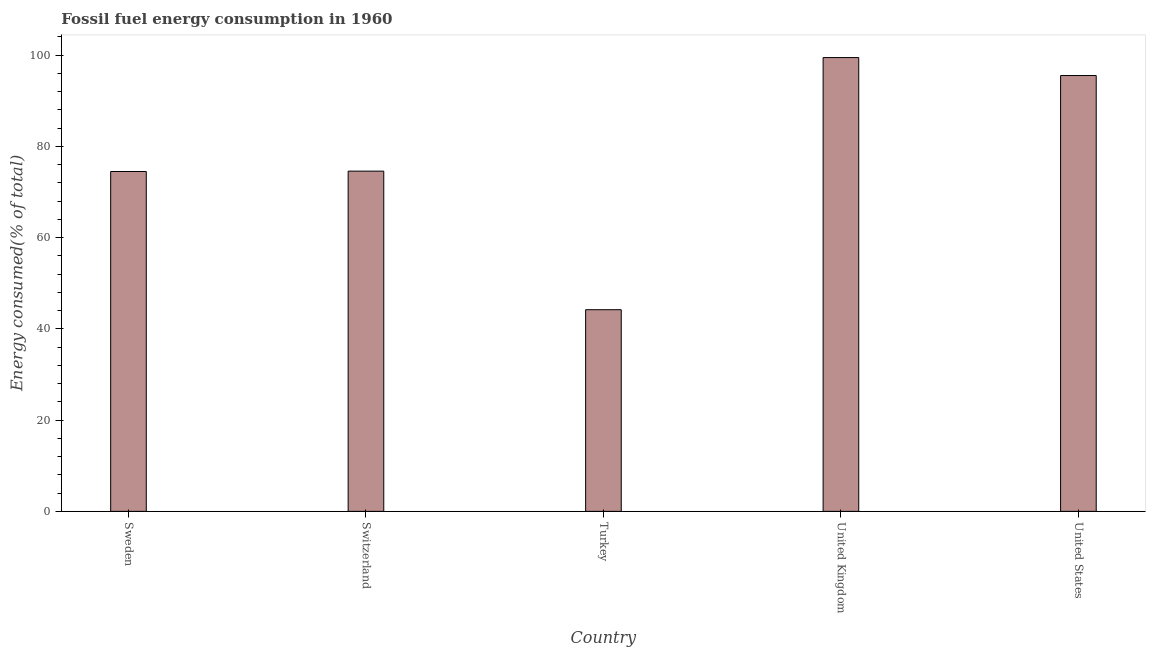What is the title of the graph?
Provide a short and direct response. Fossil fuel energy consumption in 1960. What is the label or title of the Y-axis?
Offer a terse response. Energy consumed(% of total). What is the fossil fuel energy consumption in United Kingdom?
Offer a terse response. 99.46. Across all countries, what is the maximum fossil fuel energy consumption?
Make the answer very short. 99.46. Across all countries, what is the minimum fossil fuel energy consumption?
Make the answer very short. 44.2. What is the sum of the fossil fuel energy consumption?
Provide a short and direct response. 388.25. What is the difference between the fossil fuel energy consumption in Turkey and United Kingdom?
Offer a terse response. -55.27. What is the average fossil fuel energy consumption per country?
Provide a short and direct response. 77.65. What is the median fossil fuel energy consumption?
Your answer should be compact. 74.57. In how many countries, is the fossil fuel energy consumption greater than 72 %?
Keep it short and to the point. 4. What is the ratio of the fossil fuel energy consumption in Sweden to that in Turkey?
Ensure brevity in your answer.  1.69. Is the difference between the fossil fuel energy consumption in Switzerland and Turkey greater than the difference between any two countries?
Keep it short and to the point. No. What is the difference between the highest and the second highest fossil fuel energy consumption?
Provide a short and direct response. 3.94. What is the difference between the highest and the lowest fossil fuel energy consumption?
Give a very brief answer. 55.27. Are all the bars in the graph horizontal?
Offer a terse response. No. Are the values on the major ticks of Y-axis written in scientific E-notation?
Your answer should be very brief. No. What is the Energy consumed(% of total) of Sweden?
Your answer should be very brief. 74.49. What is the Energy consumed(% of total) in Switzerland?
Your answer should be compact. 74.57. What is the Energy consumed(% of total) of Turkey?
Provide a succinct answer. 44.2. What is the Energy consumed(% of total) in United Kingdom?
Give a very brief answer. 99.46. What is the Energy consumed(% of total) of United States?
Provide a short and direct response. 95.53. What is the difference between the Energy consumed(% of total) in Sweden and Switzerland?
Give a very brief answer. -0.08. What is the difference between the Energy consumed(% of total) in Sweden and Turkey?
Give a very brief answer. 30.29. What is the difference between the Energy consumed(% of total) in Sweden and United Kingdom?
Your answer should be very brief. -24.97. What is the difference between the Energy consumed(% of total) in Sweden and United States?
Your response must be concise. -21.03. What is the difference between the Energy consumed(% of total) in Switzerland and Turkey?
Give a very brief answer. 30.37. What is the difference between the Energy consumed(% of total) in Switzerland and United Kingdom?
Provide a succinct answer. -24.89. What is the difference between the Energy consumed(% of total) in Switzerland and United States?
Your answer should be compact. -20.95. What is the difference between the Energy consumed(% of total) in Turkey and United Kingdom?
Your answer should be very brief. -55.27. What is the difference between the Energy consumed(% of total) in Turkey and United States?
Keep it short and to the point. -51.33. What is the difference between the Energy consumed(% of total) in United Kingdom and United States?
Your answer should be compact. 3.94. What is the ratio of the Energy consumed(% of total) in Sweden to that in Turkey?
Offer a very short reply. 1.69. What is the ratio of the Energy consumed(% of total) in Sweden to that in United Kingdom?
Keep it short and to the point. 0.75. What is the ratio of the Energy consumed(% of total) in Sweden to that in United States?
Your response must be concise. 0.78. What is the ratio of the Energy consumed(% of total) in Switzerland to that in Turkey?
Ensure brevity in your answer.  1.69. What is the ratio of the Energy consumed(% of total) in Switzerland to that in United States?
Provide a short and direct response. 0.78. What is the ratio of the Energy consumed(% of total) in Turkey to that in United Kingdom?
Ensure brevity in your answer.  0.44. What is the ratio of the Energy consumed(% of total) in Turkey to that in United States?
Keep it short and to the point. 0.46. What is the ratio of the Energy consumed(% of total) in United Kingdom to that in United States?
Make the answer very short. 1.04. 